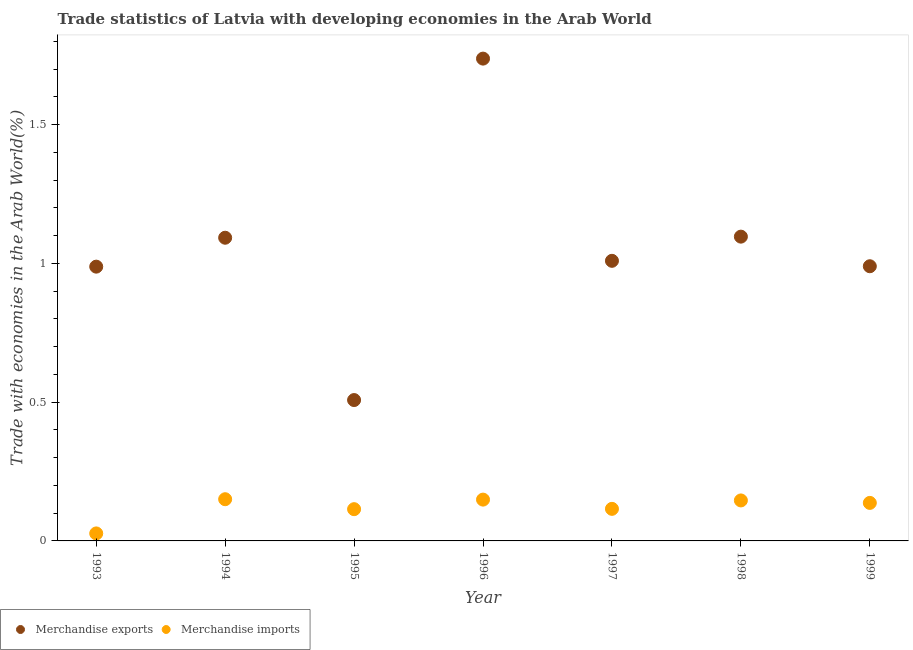How many different coloured dotlines are there?
Give a very brief answer. 2. What is the merchandise imports in 1999?
Make the answer very short. 0.14. Across all years, what is the maximum merchandise exports?
Keep it short and to the point. 1.74. Across all years, what is the minimum merchandise imports?
Offer a very short reply. 0.03. In which year was the merchandise imports minimum?
Ensure brevity in your answer.  1993. What is the total merchandise exports in the graph?
Your answer should be very brief. 7.42. What is the difference between the merchandise exports in 1998 and that in 1999?
Provide a succinct answer. 0.11. What is the difference between the merchandise imports in 1993 and the merchandise exports in 1996?
Keep it short and to the point. -1.71. What is the average merchandise exports per year?
Your answer should be very brief. 1.06. In the year 1997, what is the difference between the merchandise exports and merchandise imports?
Offer a very short reply. 0.89. In how many years, is the merchandise exports greater than 0.5 %?
Your response must be concise. 7. What is the ratio of the merchandise imports in 1993 to that in 1999?
Keep it short and to the point. 0.2. Is the difference between the merchandise imports in 1993 and 1995 greater than the difference between the merchandise exports in 1993 and 1995?
Keep it short and to the point. No. What is the difference between the highest and the second highest merchandise imports?
Ensure brevity in your answer.  0. What is the difference between the highest and the lowest merchandise imports?
Your answer should be very brief. 0.12. In how many years, is the merchandise imports greater than the average merchandise imports taken over all years?
Offer a very short reply. 4. Is the sum of the merchandise imports in 1994 and 1997 greater than the maximum merchandise exports across all years?
Offer a terse response. No. Does the merchandise imports monotonically increase over the years?
Offer a very short reply. No. Is the merchandise exports strictly greater than the merchandise imports over the years?
Your answer should be compact. Yes. What is the difference between two consecutive major ticks on the Y-axis?
Provide a short and direct response. 0.5. Does the graph contain grids?
Provide a succinct answer. No. Where does the legend appear in the graph?
Offer a very short reply. Bottom left. How are the legend labels stacked?
Keep it short and to the point. Horizontal. What is the title of the graph?
Provide a succinct answer. Trade statistics of Latvia with developing economies in the Arab World. Does "Revenue" appear as one of the legend labels in the graph?
Make the answer very short. No. What is the label or title of the Y-axis?
Offer a terse response. Trade with economies in the Arab World(%). What is the Trade with economies in the Arab World(%) of Merchandise exports in 1993?
Offer a very short reply. 0.99. What is the Trade with economies in the Arab World(%) of Merchandise imports in 1993?
Provide a succinct answer. 0.03. What is the Trade with economies in the Arab World(%) of Merchandise exports in 1994?
Offer a very short reply. 1.09. What is the Trade with economies in the Arab World(%) in Merchandise imports in 1994?
Ensure brevity in your answer.  0.15. What is the Trade with economies in the Arab World(%) of Merchandise exports in 1995?
Keep it short and to the point. 0.51. What is the Trade with economies in the Arab World(%) of Merchandise imports in 1995?
Give a very brief answer. 0.11. What is the Trade with economies in the Arab World(%) of Merchandise exports in 1996?
Your answer should be compact. 1.74. What is the Trade with economies in the Arab World(%) of Merchandise imports in 1996?
Your answer should be compact. 0.15. What is the Trade with economies in the Arab World(%) in Merchandise exports in 1997?
Make the answer very short. 1.01. What is the Trade with economies in the Arab World(%) of Merchandise imports in 1997?
Keep it short and to the point. 0.12. What is the Trade with economies in the Arab World(%) of Merchandise exports in 1998?
Your answer should be compact. 1.1. What is the Trade with economies in the Arab World(%) of Merchandise imports in 1998?
Offer a terse response. 0.15. What is the Trade with economies in the Arab World(%) of Merchandise exports in 1999?
Offer a terse response. 0.99. What is the Trade with economies in the Arab World(%) in Merchandise imports in 1999?
Provide a short and direct response. 0.14. Across all years, what is the maximum Trade with economies in the Arab World(%) of Merchandise exports?
Your answer should be very brief. 1.74. Across all years, what is the maximum Trade with economies in the Arab World(%) in Merchandise imports?
Provide a short and direct response. 0.15. Across all years, what is the minimum Trade with economies in the Arab World(%) in Merchandise exports?
Ensure brevity in your answer.  0.51. Across all years, what is the minimum Trade with economies in the Arab World(%) in Merchandise imports?
Give a very brief answer. 0.03. What is the total Trade with economies in the Arab World(%) of Merchandise exports in the graph?
Provide a short and direct response. 7.42. What is the total Trade with economies in the Arab World(%) of Merchandise imports in the graph?
Give a very brief answer. 0.84. What is the difference between the Trade with economies in the Arab World(%) of Merchandise exports in 1993 and that in 1994?
Your answer should be compact. -0.1. What is the difference between the Trade with economies in the Arab World(%) in Merchandise imports in 1993 and that in 1994?
Your answer should be compact. -0.12. What is the difference between the Trade with economies in the Arab World(%) in Merchandise exports in 1993 and that in 1995?
Give a very brief answer. 0.48. What is the difference between the Trade with economies in the Arab World(%) of Merchandise imports in 1993 and that in 1995?
Your answer should be compact. -0.09. What is the difference between the Trade with economies in the Arab World(%) in Merchandise exports in 1993 and that in 1996?
Keep it short and to the point. -0.75. What is the difference between the Trade with economies in the Arab World(%) of Merchandise imports in 1993 and that in 1996?
Make the answer very short. -0.12. What is the difference between the Trade with economies in the Arab World(%) of Merchandise exports in 1993 and that in 1997?
Make the answer very short. -0.02. What is the difference between the Trade with economies in the Arab World(%) in Merchandise imports in 1993 and that in 1997?
Provide a short and direct response. -0.09. What is the difference between the Trade with economies in the Arab World(%) in Merchandise exports in 1993 and that in 1998?
Make the answer very short. -0.11. What is the difference between the Trade with economies in the Arab World(%) of Merchandise imports in 1993 and that in 1998?
Your response must be concise. -0.12. What is the difference between the Trade with economies in the Arab World(%) of Merchandise exports in 1993 and that in 1999?
Make the answer very short. -0. What is the difference between the Trade with economies in the Arab World(%) in Merchandise imports in 1993 and that in 1999?
Keep it short and to the point. -0.11. What is the difference between the Trade with economies in the Arab World(%) in Merchandise exports in 1994 and that in 1995?
Give a very brief answer. 0.58. What is the difference between the Trade with economies in the Arab World(%) of Merchandise imports in 1994 and that in 1995?
Offer a very short reply. 0.04. What is the difference between the Trade with economies in the Arab World(%) in Merchandise exports in 1994 and that in 1996?
Offer a terse response. -0.65. What is the difference between the Trade with economies in the Arab World(%) in Merchandise imports in 1994 and that in 1996?
Offer a terse response. 0. What is the difference between the Trade with economies in the Arab World(%) of Merchandise exports in 1994 and that in 1997?
Make the answer very short. 0.08. What is the difference between the Trade with economies in the Arab World(%) in Merchandise imports in 1994 and that in 1997?
Make the answer very short. 0.03. What is the difference between the Trade with economies in the Arab World(%) in Merchandise exports in 1994 and that in 1998?
Your answer should be very brief. -0. What is the difference between the Trade with economies in the Arab World(%) of Merchandise imports in 1994 and that in 1998?
Give a very brief answer. 0. What is the difference between the Trade with economies in the Arab World(%) of Merchandise exports in 1994 and that in 1999?
Offer a very short reply. 0.1. What is the difference between the Trade with economies in the Arab World(%) in Merchandise imports in 1994 and that in 1999?
Ensure brevity in your answer.  0.01. What is the difference between the Trade with economies in the Arab World(%) of Merchandise exports in 1995 and that in 1996?
Provide a short and direct response. -1.23. What is the difference between the Trade with economies in the Arab World(%) in Merchandise imports in 1995 and that in 1996?
Make the answer very short. -0.03. What is the difference between the Trade with economies in the Arab World(%) of Merchandise exports in 1995 and that in 1997?
Ensure brevity in your answer.  -0.5. What is the difference between the Trade with economies in the Arab World(%) in Merchandise imports in 1995 and that in 1997?
Offer a terse response. -0. What is the difference between the Trade with economies in the Arab World(%) in Merchandise exports in 1995 and that in 1998?
Your answer should be compact. -0.59. What is the difference between the Trade with economies in the Arab World(%) of Merchandise imports in 1995 and that in 1998?
Provide a succinct answer. -0.03. What is the difference between the Trade with economies in the Arab World(%) in Merchandise exports in 1995 and that in 1999?
Provide a short and direct response. -0.48. What is the difference between the Trade with economies in the Arab World(%) in Merchandise imports in 1995 and that in 1999?
Provide a short and direct response. -0.02. What is the difference between the Trade with economies in the Arab World(%) of Merchandise exports in 1996 and that in 1997?
Your answer should be very brief. 0.73. What is the difference between the Trade with economies in the Arab World(%) of Merchandise exports in 1996 and that in 1998?
Ensure brevity in your answer.  0.64. What is the difference between the Trade with economies in the Arab World(%) in Merchandise imports in 1996 and that in 1998?
Ensure brevity in your answer.  0. What is the difference between the Trade with economies in the Arab World(%) in Merchandise exports in 1996 and that in 1999?
Offer a very short reply. 0.75. What is the difference between the Trade with economies in the Arab World(%) in Merchandise imports in 1996 and that in 1999?
Ensure brevity in your answer.  0.01. What is the difference between the Trade with economies in the Arab World(%) of Merchandise exports in 1997 and that in 1998?
Keep it short and to the point. -0.09. What is the difference between the Trade with economies in the Arab World(%) of Merchandise imports in 1997 and that in 1998?
Offer a terse response. -0.03. What is the difference between the Trade with economies in the Arab World(%) in Merchandise exports in 1997 and that in 1999?
Your answer should be compact. 0.02. What is the difference between the Trade with economies in the Arab World(%) of Merchandise imports in 1997 and that in 1999?
Ensure brevity in your answer.  -0.02. What is the difference between the Trade with economies in the Arab World(%) in Merchandise exports in 1998 and that in 1999?
Your answer should be compact. 0.11. What is the difference between the Trade with economies in the Arab World(%) of Merchandise imports in 1998 and that in 1999?
Offer a terse response. 0.01. What is the difference between the Trade with economies in the Arab World(%) of Merchandise exports in 1993 and the Trade with economies in the Arab World(%) of Merchandise imports in 1994?
Your answer should be compact. 0.84. What is the difference between the Trade with economies in the Arab World(%) in Merchandise exports in 1993 and the Trade with economies in the Arab World(%) in Merchandise imports in 1995?
Provide a short and direct response. 0.87. What is the difference between the Trade with economies in the Arab World(%) of Merchandise exports in 1993 and the Trade with economies in the Arab World(%) of Merchandise imports in 1996?
Provide a short and direct response. 0.84. What is the difference between the Trade with economies in the Arab World(%) in Merchandise exports in 1993 and the Trade with economies in the Arab World(%) in Merchandise imports in 1997?
Provide a succinct answer. 0.87. What is the difference between the Trade with economies in the Arab World(%) of Merchandise exports in 1993 and the Trade with economies in the Arab World(%) of Merchandise imports in 1998?
Provide a succinct answer. 0.84. What is the difference between the Trade with economies in the Arab World(%) of Merchandise exports in 1993 and the Trade with economies in the Arab World(%) of Merchandise imports in 1999?
Give a very brief answer. 0.85. What is the difference between the Trade with economies in the Arab World(%) in Merchandise exports in 1994 and the Trade with economies in the Arab World(%) in Merchandise imports in 1995?
Your answer should be very brief. 0.98. What is the difference between the Trade with economies in the Arab World(%) in Merchandise exports in 1994 and the Trade with economies in the Arab World(%) in Merchandise imports in 1996?
Give a very brief answer. 0.94. What is the difference between the Trade with economies in the Arab World(%) in Merchandise exports in 1994 and the Trade with economies in the Arab World(%) in Merchandise imports in 1997?
Provide a succinct answer. 0.98. What is the difference between the Trade with economies in the Arab World(%) of Merchandise exports in 1994 and the Trade with economies in the Arab World(%) of Merchandise imports in 1998?
Keep it short and to the point. 0.95. What is the difference between the Trade with economies in the Arab World(%) in Merchandise exports in 1994 and the Trade with economies in the Arab World(%) in Merchandise imports in 1999?
Your response must be concise. 0.96. What is the difference between the Trade with economies in the Arab World(%) of Merchandise exports in 1995 and the Trade with economies in the Arab World(%) of Merchandise imports in 1996?
Your answer should be compact. 0.36. What is the difference between the Trade with economies in the Arab World(%) of Merchandise exports in 1995 and the Trade with economies in the Arab World(%) of Merchandise imports in 1997?
Ensure brevity in your answer.  0.39. What is the difference between the Trade with economies in the Arab World(%) in Merchandise exports in 1995 and the Trade with economies in the Arab World(%) in Merchandise imports in 1998?
Give a very brief answer. 0.36. What is the difference between the Trade with economies in the Arab World(%) in Merchandise exports in 1995 and the Trade with economies in the Arab World(%) in Merchandise imports in 1999?
Provide a succinct answer. 0.37. What is the difference between the Trade with economies in the Arab World(%) in Merchandise exports in 1996 and the Trade with economies in the Arab World(%) in Merchandise imports in 1997?
Offer a very short reply. 1.62. What is the difference between the Trade with economies in the Arab World(%) in Merchandise exports in 1996 and the Trade with economies in the Arab World(%) in Merchandise imports in 1998?
Give a very brief answer. 1.59. What is the difference between the Trade with economies in the Arab World(%) of Merchandise exports in 1996 and the Trade with economies in the Arab World(%) of Merchandise imports in 1999?
Offer a very short reply. 1.6. What is the difference between the Trade with economies in the Arab World(%) in Merchandise exports in 1997 and the Trade with economies in the Arab World(%) in Merchandise imports in 1998?
Give a very brief answer. 0.86. What is the difference between the Trade with economies in the Arab World(%) in Merchandise exports in 1997 and the Trade with economies in the Arab World(%) in Merchandise imports in 1999?
Your response must be concise. 0.87. What is the difference between the Trade with economies in the Arab World(%) of Merchandise exports in 1998 and the Trade with economies in the Arab World(%) of Merchandise imports in 1999?
Offer a terse response. 0.96. What is the average Trade with economies in the Arab World(%) in Merchandise exports per year?
Your answer should be very brief. 1.06. What is the average Trade with economies in the Arab World(%) of Merchandise imports per year?
Your answer should be very brief. 0.12. In the year 1993, what is the difference between the Trade with economies in the Arab World(%) in Merchandise exports and Trade with economies in the Arab World(%) in Merchandise imports?
Keep it short and to the point. 0.96. In the year 1994, what is the difference between the Trade with economies in the Arab World(%) in Merchandise exports and Trade with economies in the Arab World(%) in Merchandise imports?
Offer a terse response. 0.94. In the year 1995, what is the difference between the Trade with economies in the Arab World(%) of Merchandise exports and Trade with economies in the Arab World(%) of Merchandise imports?
Give a very brief answer. 0.39. In the year 1996, what is the difference between the Trade with economies in the Arab World(%) in Merchandise exports and Trade with economies in the Arab World(%) in Merchandise imports?
Provide a short and direct response. 1.59. In the year 1997, what is the difference between the Trade with economies in the Arab World(%) of Merchandise exports and Trade with economies in the Arab World(%) of Merchandise imports?
Keep it short and to the point. 0.89. In the year 1998, what is the difference between the Trade with economies in the Arab World(%) in Merchandise exports and Trade with economies in the Arab World(%) in Merchandise imports?
Give a very brief answer. 0.95. In the year 1999, what is the difference between the Trade with economies in the Arab World(%) of Merchandise exports and Trade with economies in the Arab World(%) of Merchandise imports?
Ensure brevity in your answer.  0.85. What is the ratio of the Trade with economies in the Arab World(%) of Merchandise exports in 1993 to that in 1994?
Your response must be concise. 0.9. What is the ratio of the Trade with economies in the Arab World(%) of Merchandise imports in 1993 to that in 1994?
Provide a succinct answer. 0.18. What is the ratio of the Trade with economies in the Arab World(%) in Merchandise exports in 1993 to that in 1995?
Give a very brief answer. 1.95. What is the ratio of the Trade with economies in the Arab World(%) in Merchandise imports in 1993 to that in 1995?
Offer a terse response. 0.24. What is the ratio of the Trade with economies in the Arab World(%) in Merchandise exports in 1993 to that in 1996?
Your answer should be compact. 0.57. What is the ratio of the Trade with economies in the Arab World(%) of Merchandise imports in 1993 to that in 1996?
Your answer should be compact. 0.18. What is the ratio of the Trade with economies in the Arab World(%) in Merchandise exports in 1993 to that in 1997?
Keep it short and to the point. 0.98. What is the ratio of the Trade with economies in the Arab World(%) of Merchandise imports in 1993 to that in 1997?
Your answer should be compact. 0.23. What is the ratio of the Trade with economies in the Arab World(%) of Merchandise exports in 1993 to that in 1998?
Make the answer very short. 0.9. What is the ratio of the Trade with economies in the Arab World(%) of Merchandise imports in 1993 to that in 1998?
Provide a short and direct response. 0.19. What is the ratio of the Trade with economies in the Arab World(%) in Merchandise imports in 1993 to that in 1999?
Make the answer very short. 0.2. What is the ratio of the Trade with economies in the Arab World(%) in Merchandise exports in 1994 to that in 1995?
Your answer should be very brief. 2.15. What is the ratio of the Trade with economies in the Arab World(%) in Merchandise imports in 1994 to that in 1995?
Ensure brevity in your answer.  1.31. What is the ratio of the Trade with economies in the Arab World(%) in Merchandise exports in 1994 to that in 1996?
Your answer should be compact. 0.63. What is the ratio of the Trade with economies in the Arab World(%) of Merchandise imports in 1994 to that in 1996?
Provide a short and direct response. 1.01. What is the ratio of the Trade with economies in the Arab World(%) in Merchandise exports in 1994 to that in 1997?
Offer a very short reply. 1.08. What is the ratio of the Trade with economies in the Arab World(%) of Merchandise imports in 1994 to that in 1997?
Offer a very short reply. 1.3. What is the ratio of the Trade with economies in the Arab World(%) in Merchandise imports in 1994 to that in 1998?
Give a very brief answer. 1.03. What is the ratio of the Trade with economies in the Arab World(%) in Merchandise exports in 1994 to that in 1999?
Ensure brevity in your answer.  1.1. What is the ratio of the Trade with economies in the Arab World(%) of Merchandise imports in 1994 to that in 1999?
Offer a very short reply. 1.1. What is the ratio of the Trade with economies in the Arab World(%) in Merchandise exports in 1995 to that in 1996?
Provide a succinct answer. 0.29. What is the ratio of the Trade with economies in the Arab World(%) in Merchandise imports in 1995 to that in 1996?
Offer a terse response. 0.77. What is the ratio of the Trade with economies in the Arab World(%) of Merchandise exports in 1995 to that in 1997?
Give a very brief answer. 0.5. What is the ratio of the Trade with economies in the Arab World(%) in Merchandise imports in 1995 to that in 1997?
Ensure brevity in your answer.  0.99. What is the ratio of the Trade with economies in the Arab World(%) in Merchandise exports in 1995 to that in 1998?
Provide a succinct answer. 0.46. What is the ratio of the Trade with economies in the Arab World(%) of Merchandise imports in 1995 to that in 1998?
Make the answer very short. 0.78. What is the ratio of the Trade with economies in the Arab World(%) of Merchandise exports in 1995 to that in 1999?
Offer a very short reply. 0.51. What is the ratio of the Trade with economies in the Arab World(%) in Merchandise imports in 1995 to that in 1999?
Your answer should be very brief. 0.84. What is the ratio of the Trade with economies in the Arab World(%) in Merchandise exports in 1996 to that in 1997?
Offer a very short reply. 1.72. What is the ratio of the Trade with economies in the Arab World(%) in Merchandise imports in 1996 to that in 1997?
Give a very brief answer. 1.29. What is the ratio of the Trade with economies in the Arab World(%) in Merchandise exports in 1996 to that in 1998?
Provide a short and direct response. 1.59. What is the ratio of the Trade with economies in the Arab World(%) in Merchandise imports in 1996 to that in 1998?
Ensure brevity in your answer.  1.02. What is the ratio of the Trade with economies in the Arab World(%) in Merchandise exports in 1996 to that in 1999?
Keep it short and to the point. 1.76. What is the ratio of the Trade with economies in the Arab World(%) of Merchandise imports in 1996 to that in 1999?
Your answer should be very brief. 1.09. What is the ratio of the Trade with economies in the Arab World(%) of Merchandise exports in 1997 to that in 1998?
Your response must be concise. 0.92. What is the ratio of the Trade with economies in the Arab World(%) of Merchandise imports in 1997 to that in 1998?
Your answer should be compact. 0.79. What is the ratio of the Trade with economies in the Arab World(%) of Merchandise exports in 1997 to that in 1999?
Provide a succinct answer. 1.02. What is the ratio of the Trade with economies in the Arab World(%) of Merchandise imports in 1997 to that in 1999?
Give a very brief answer. 0.84. What is the ratio of the Trade with economies in the Arab World(%) of Merchandise exports in 1998 to that in 1999?
Make the answer very short. 1.11. What is the ratio of the Trade with economies in the Arab World(%) of Merchandise imports in 1998 to that in 1999?
Offer a terse response. 1.06. What is the difference between the highest and the second highest Trade with economies in the Arab World(%) in Merchandise exports?
Offer a very short reply. 0.64. What is the difference between the highest and the second highest Trade with economies in the Arab World(%) of Merchandise imports?
Provide a succinct answer. 0. What is the difference between the highest and the lowest Trade with economies in the Arab World(%) of Merchandise exports?
Offer a very short reply. 1.23. What is the difference between the highest and the lowest Trade with economies in the Arab World(%) of Merchandise imports?
Your answer should be very brief. 0.12. 